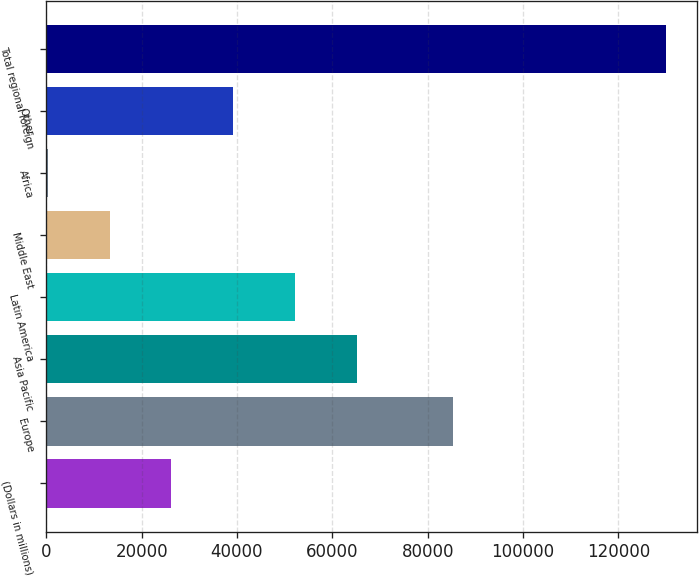<chart> <loc_0><loc_0><loc_500><loc_500><bar_chart><fcel>(Dollars in millions)<fcel>Europe<fcel>Asia Pacific<fcel>Latin America<fcel>Middle East<fcel>Africa<fcel>Other<fcel>Total regional foreign<nl><fcel>26241.4<fcel>85279<fcel>65128<fcel>52165.8<fcel>13279.2<fcel>317<fcel>39203.6<fcel>129939<nl></chart> 